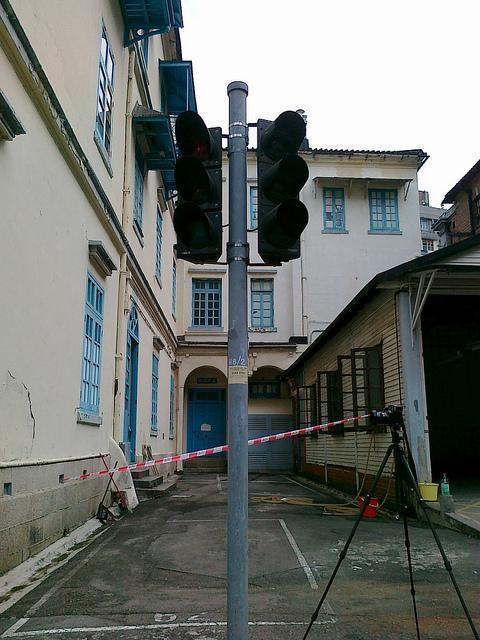How many lights are on the streetlight?
Give a very brief answer. 6. How many traffic lights are there?
Give a very brief answer. 2. 